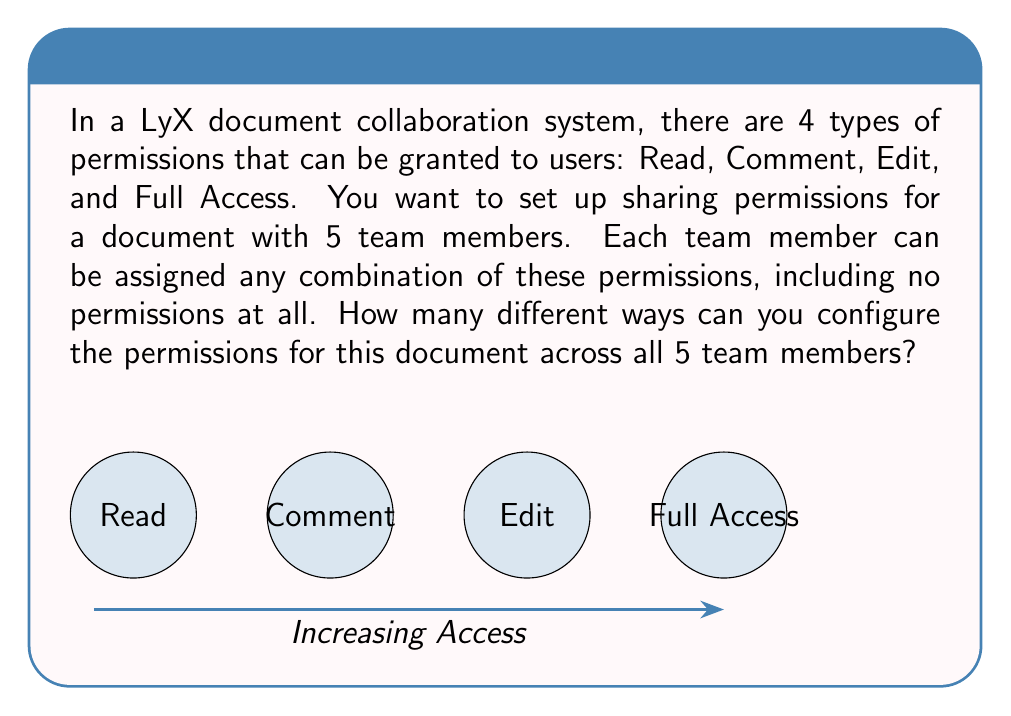Give your solution to this math problem. Let's approach this step-by-step:

1) For each team member, we need to decide which permissions to grant. Each permission can be either granted or not granted, independent of the others.

2) This means for each permission type, we have 2 choices: grant it or not grant it.

3) Since there are 4 permission types, and each can be independently granted or not, for each team member we have $2^4 = 16$ possible permission configurations.

4) Now, we need to make this choice for each of the 5 team members. The choices for each member are independent of the others.

5) When we have independent choices like this, we multiply the number of possibilities for each choice. This is known as the multiplication principle in combinatorics.

6) Therefore, the total number of ways to configure permissions is:

   $$(2^4)^5 = 16^5 = 1,048,576$$

This can also be written as:

$$2^{4 \times 5} = 2^{20} = 1,048,576$$

This large number demonstrates why efficient permission management is crucial in document collaboration systems!
Answer: $1,048,576$ 